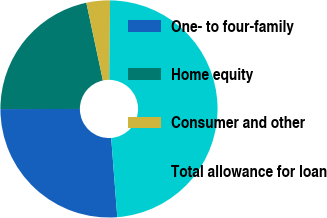Convert chart to OTSL. <chart><loc_0><loc_0><loc_500><loc_500><pie_chart><fcel>One- to four-family<fcel>Home equity<fcel>Consumer and other<fcel>Total allowance for loan<nl><fcel>26.2%<fcel>21.68%<fcel>3.5%<fcel>48.62%<nl></chart> 